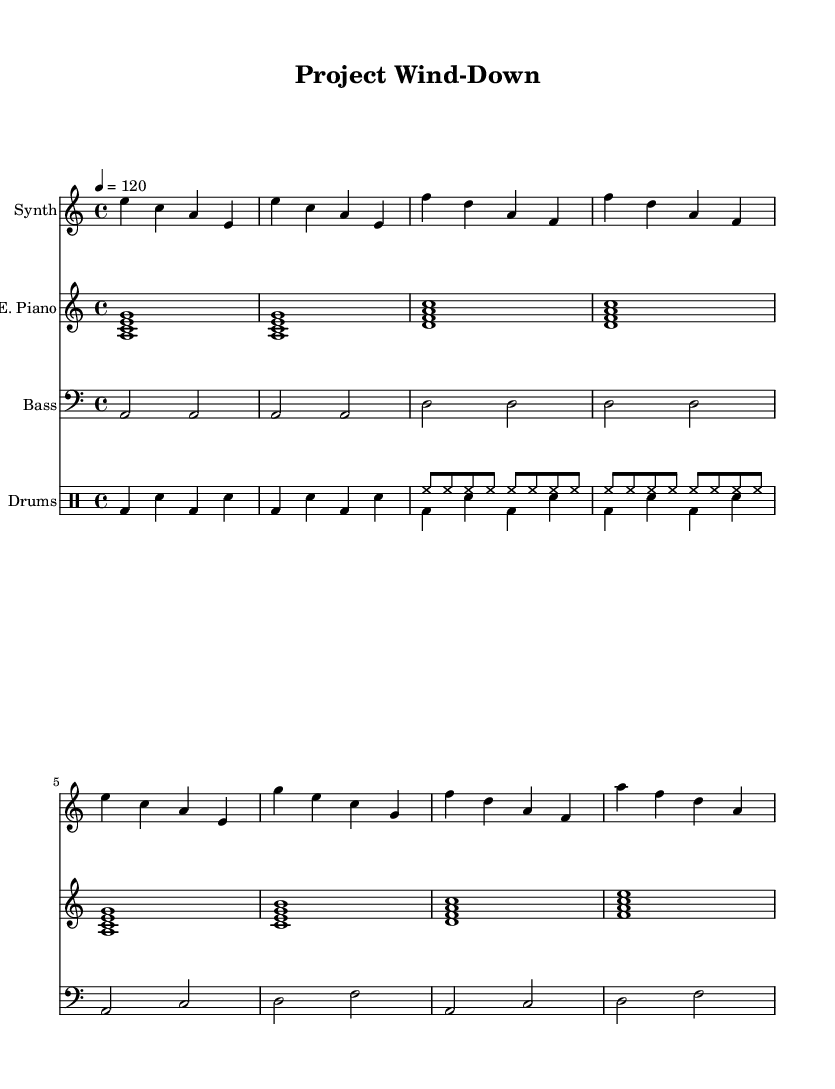What is the key signature of this music? The key signature of the piece is A minor, which has no sharps or flats shown. This can be determined by observing the initial setup in the global section of the music, which indicates the key.
Answer: A minor What is the time signature of this music? The time signature indicated in the global section is 4/4, which signifies that there are four beats per measure and the quarter note gets one beat. This can be confirmed by looking at the global settings where the time signature is defined.
Answer: 4/4 What is the tempo of this music? The tempo is set at quarter note equals 120, which shows how many beats occur in a minute. This is found in the global section where the tempo marking is provided.
Answer: 120 How many measures are in the intro section? The intro section consists of four measures as visualized at the beginning of the music sheet. Each measure is represented distinctly in the score before the main theme begins.
Answer: 4 Which instrument is playing the main melody? The instrument designated to play the main melody is the Synth. This is evident from the staff naming at the start of the melody section where it is marked "Synth."
Answer: Synth What chord is played at the beginning of the intro? The beginning of the intro features the chord A minor, represented by the notes A, C, and E played simultaneously. This can be identified from the first measure of the electric piano staff.
Answer: A minor How does the drum part contribute to the overall feel of the track? The drum part employs a steady beat with a kick drum and snare alternating in a four-beat pattern, which enhances the danceable rhythm typical of deep house tracks. This is assessed by looking at the rhythmic structure in the drum staff, showing the interaction of drum sounds.
Answer: Steady rhythm 